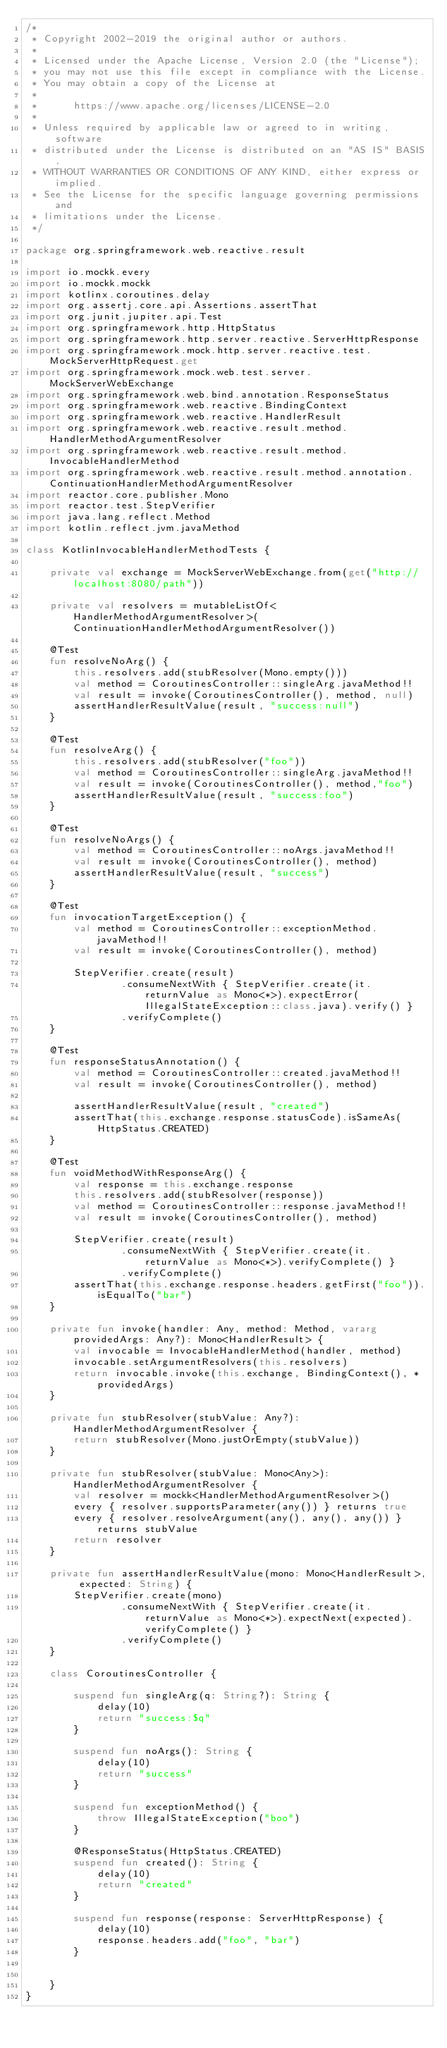Convert code to text. <code><loc_0><loc_0><loc_500><loc_500><_Kotlin_>/*
 * Copyright 2002-2019 the original author or authors.
 *
 * Licensed under the Apache License, Version 2.0 (the "License");
 * you may not use this file except in compliance with the License.
 * You may obtain a copy of the License at
 *
 *      https://www.apache.org/licenses/LICENSE-2.0
 *
 * Unless required by applicable law or agreed to in writing, software
 * distributed under the License is distributed on an "AS IS" BASIS,
 * WITHOUT WARRANTIES OR CONDITIONS OF ANY KIND, either express or implied.
 * See the License for the specific language governing permissions and
 * limitations under the License.
 */

package org.springframework.web.reactive.result

import io.mockk.every
import io.mockk.mockk
import kotlinx.coroutines.delay
import org.assertj.core.api.Assertions.assertThat
import org.junit.jupiter.api.Test
import org.springframework.http.HttpStatus
import org.springframework.http.server.reactive.ServerHttpResponse
import org.springframework.mock.http.server.reactive.test.MockServerHttpRequest.get
import org.springframework.mock.web.test.server.MockServerWebExchange
import org.springframework.web.bind.annotation.ResponseStatus
import org.springframework.web.reactive.BindingContext
import org.springframework.web.reactive.HandlerResult
import org.springframework.web.reactive.result.method.HandlerMethodArgumentResolver
import org.springframework.web.reactive.result.method.InvocableHandlerMethod
import org.springframework.web.reactive.result.method.annotation.ContinuationHandlerMethodArgumentResolver
import reactor.core.publisher.Mono
import reactor.test.StepVerifier
import java.lang.reflect.Method
import kotlin.reflect.jvm.javaMethod

class KotlinInvocableHandlerMethodTests {

	private val exchange = MockServerWebExchange.from(get("http://localhost:8080/path"))

	private val resolvers = mutableListOf<HandlerMethodArgumentResolver>(ContinuationHandlerMethodArgumentResolver())

	@Test
	fun resolveNoArg() {
		this.resolvers.add(stubResolver(Mono.empty()))
		val method = CoroutinesController::singleArg.javaMethod!!
		val result = invoke(CoroutinesController(), method, null)
		assertHandlerResultValue(result, "success:null")
	}

	@Test
	fun resolveArg() {
		this.resolvers.add(stubResolver("foo"))
		val method = CoroutinesController::singleArg.javaMethod!!
		val result = invoke(CoroutinesController(), method,"foo")
		assertHandlerResultValue(result, "success:foo")
	}

	@Test
	fun resolveNoArgs() {
		val method = CoroutinesController::noArgs.javaMethod!!
		val result = invoke(CoroutinesController(), method)
		assertHandlerResultValue(result, "success")
	}

	@Test
	fun invocationTargetException() {
		val method = CoroutinesController::exceptionMethod.javaMethod!!
		val result = invoke(CoroutinesController(), method)

		StepVerifier.create(result)
				.consumeNextWith { StepVerifier.create(it.returnValue as Mono<*>).expectError(IllegalStateException::class.java).verify() }
				.verifyComplete()
	}

	@Test
	fun responseStatusAnnotation() {
		val method = CoroutinesController::created.javaMethod!!
		val result = invoke(CoroutinesController(), method)

		assertHandlerResultValue(result, "created")
		assertThat(this.exchange.response.statusCode).isSameAs(HttpStatus.CREATED)
	}

	@Test
	fun voidMethodWithResponseArg() {
		val response = this.exchange.response
		this.resolvers.add(stubResolver(response))
		val method = CoroutinesController::response.javaMethod!!
		val result = invoke(CoroutinesController(), method)

		StepVerifier.create(result)
				.consumeNextWith { StepVerifier.create(it.returnValue as Mono<*>).verifyComplete() }
				.verifyComplete()
		assertThat(this.exchange.response.headers.getFirst("foo")).isEqualTo("bar")
	}

	private fun invoke(handler: Any, method: Method, vararg providedArgs: Any?): Mono<HandlerResult> {
		val invocable = InvocableHandlerMethod(handler, method)
		invocable.setArgumentResolvers(this.resolvers)
		return invocable.invoke(this.exchange, BindingContext(), *providedArgs)
	}

	private fun stubResolver(stubValue: Any?): HandlerMethodArgumentResolver {
		return stubResolver(Mono.justOrEmpty(stubValue))
	}

	private fun stubResolver(stubValue: Mono<Any>): HandlerMethodArgumentResolver {
		val resolver = mockk<HandlerMethodArgumentResolver>()
		every { resolver.supportsParameter(any()) } returns true
		every { resolver.resolveArgument(any(), any(), any()) } returns stubValue
		return resolver
	}

	private fun assertHandlerResultValue(mono: Mono<HandlerResult>, expected: String) {
		StepVerifier.create(mono)
				.consumeNextWith { StepVerifier.create(it.returnValue as Mono<*>).expectNext(expected).verifyComplete() }
				.verifyComplete()
	}

	class CoroutinesController {

		suspend fun singleArg(q: String?): String {
			delay(10)
			return "success:$q"
		}

		suspend fun noArgs(): String {
			delay(10)
			return "success"
		}

		suspend fun exceptionMethod() {
			throw IllegalStateException("boo")
		}

		@ResponseStatus(HttpStatus.CREATED)
		suspend fun created(): String {
			delay(10)
			return "created"
		}

		suspend fun response(response: ServerHttpResponse) {
			delay(10)
			response.headers.add("foo", "bar")
		}


	}
}</code> 